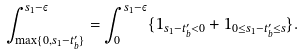<formula> <loc_0><loc_0><loc_500><loc_500>\int _ { \max \{ 0 , s _ { 1 } - t _ { b } ^ { \prime } \} } ^ { s _ { 1 } - \varepsilon } = \int _ { 0 } ^ { s _ { 1 } - \varepsilon } \{ 1 _ { s _ { 1 } - t _ { b } ^ { \prime } < 0 } + 1 _ { 0 \leq s _ { 1 } - t _ { b } ^ { \prime } \leq s } \} .</formula> 